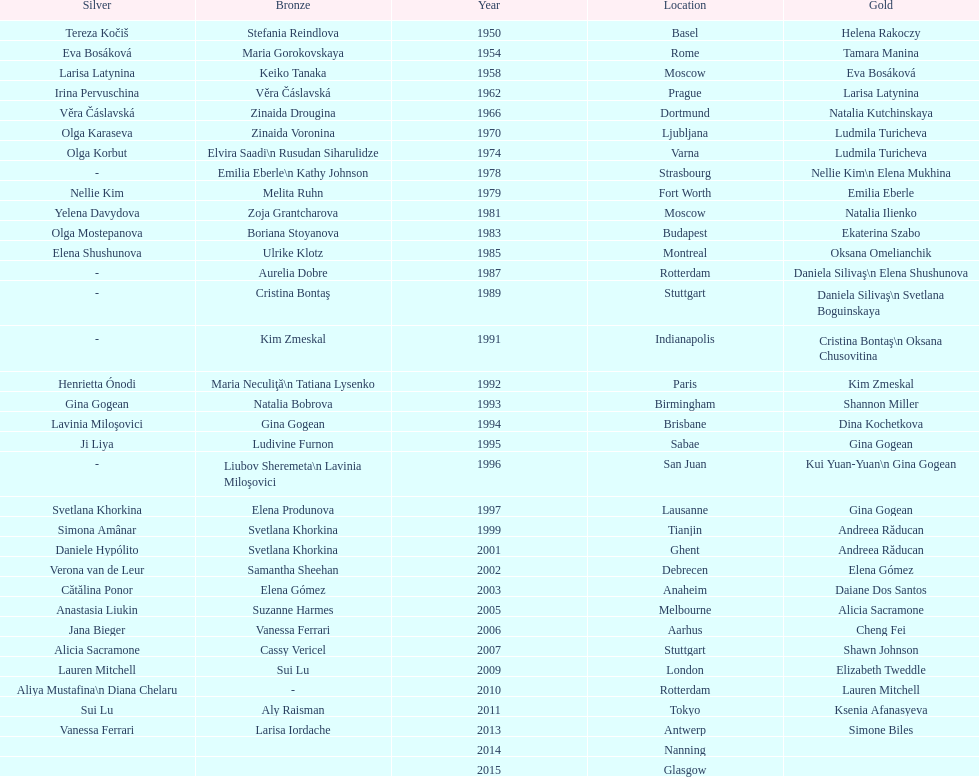How many consecutive floor exercise gold medals did romanian star andreea raducan win at the world championships? 2. 